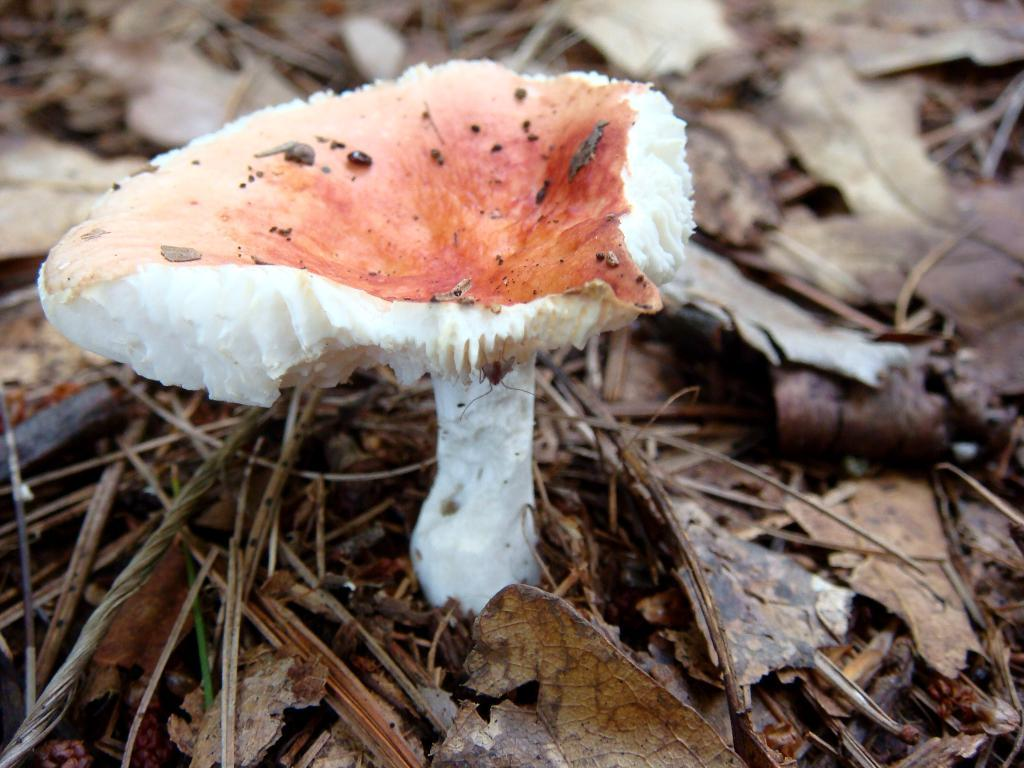What type of vegetation can be seen in the image? There are mushrooms and grass in the image. What else can be found on the ground in the image? Dried leaves are present in the image. What trick can be performed with the mushrooms in the image? There is no trick being performed with the mushrooms in the image, as they are simply growing in their natural environment. 